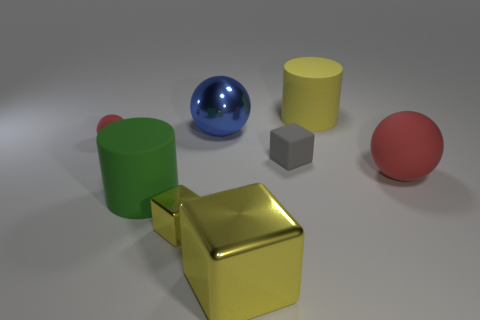Is the small red sphere made of the same material as the yellow cube to the left of the big cube?
Make the answer very short. No. What number of other things are there of the same size as the blue thing?
Make the answer very short. 4. There is a yellow block to the right of the tiny cube that is on the left side of the big blue metallic object; are there any matte spheres that are to the left of it?
Offer a terse response. Yes. What is the size of the yellow rubber object?
Offer a very short reply. Large. There is a matte cylinder that is in front of the yellow matte cylinder; what is its size?
Your response must be concise. Large. There is a red ball that is left of the green cylinder; is its size the same as the large blue shiny sphere?
Ensure brevity in your answer.  No. Is there any other thing that has the same color as the tiny rubber ball?
Your answer should be very brief. Yes. The small red rubber thing is what shape?
Keep it short and to the point. Sphere. How many small objects are in front of the small red rubber ball and to the left of the big blue thing?
Give a very brief answer. 1. Does the small shiny block have the same color as the big block?
Ensure brevity in your answer.  Yes. 